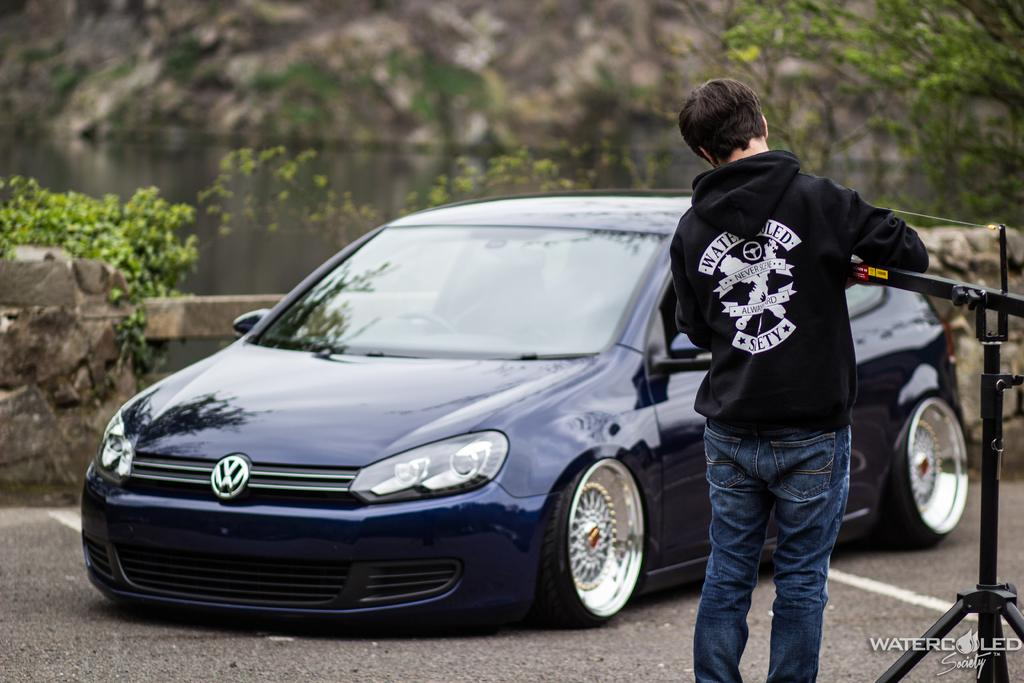What is on the right side of the image? There is a man on the right side of the image. What is the man holding in the image? The man is holding a metal rod. What is in front of the man in the image? There is a car in front of the man. What type of natural vegetation can be seen in the image? There are trees visible in the image. What can be found in the bottom right-hand corner of the image? There is some text in the bottom right-hand corner of the image. What type of bait is the man using to catch fish in the image? There is no indication of fishing or bait in the image; the man is holding a metal rod, but its purpose is not specified. What story is the man telling to the trees in the image? There is no story being told in the image; the man is simply standing with a metal rod, and the trees are in the background. 